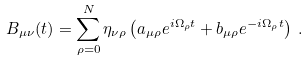<formula> <loc_0><loc_0><loc_500><loc_500>B _ { \mu \nu } ( t ) = \sum _ { \rho = 0 } ^ { N } \eta _ { \nu \rho } \left ( a _ { \mu \rho } e ^ { i \Omega _ { \rho } t } + b _ { \mu \rho } e ^ { - i \Omega _ { \rho } t } \right ) \, .</formula> 